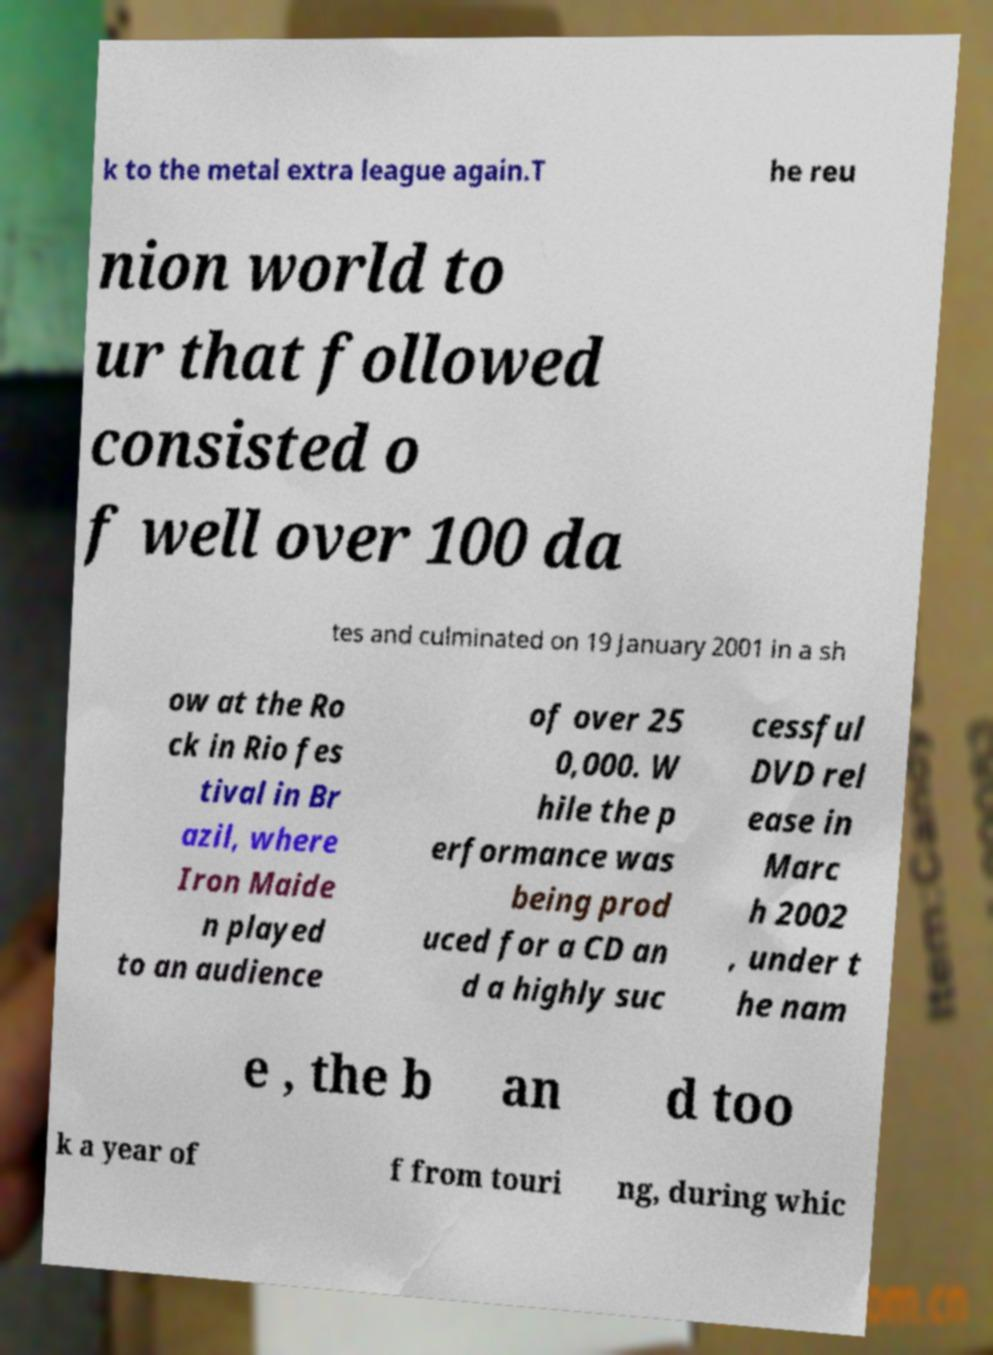Please read and relay the text visible in this image. What does it say? k to the metal extra league again.T he reu nion world to ur that followed consisted o f well over 100 da tes and culminated on 19 January 2001 in a sh ow at the Ro ck in Rio fes tival in Br azil, where Iron Maide n played to an audience of over 25 0,000. W hile the p erformance was being prod uced for a CD an d a highly suc cessful DVD rel ease in Marc h 2002 , under t he nam e , the b an d too k a year of f from touri ng, during whic 